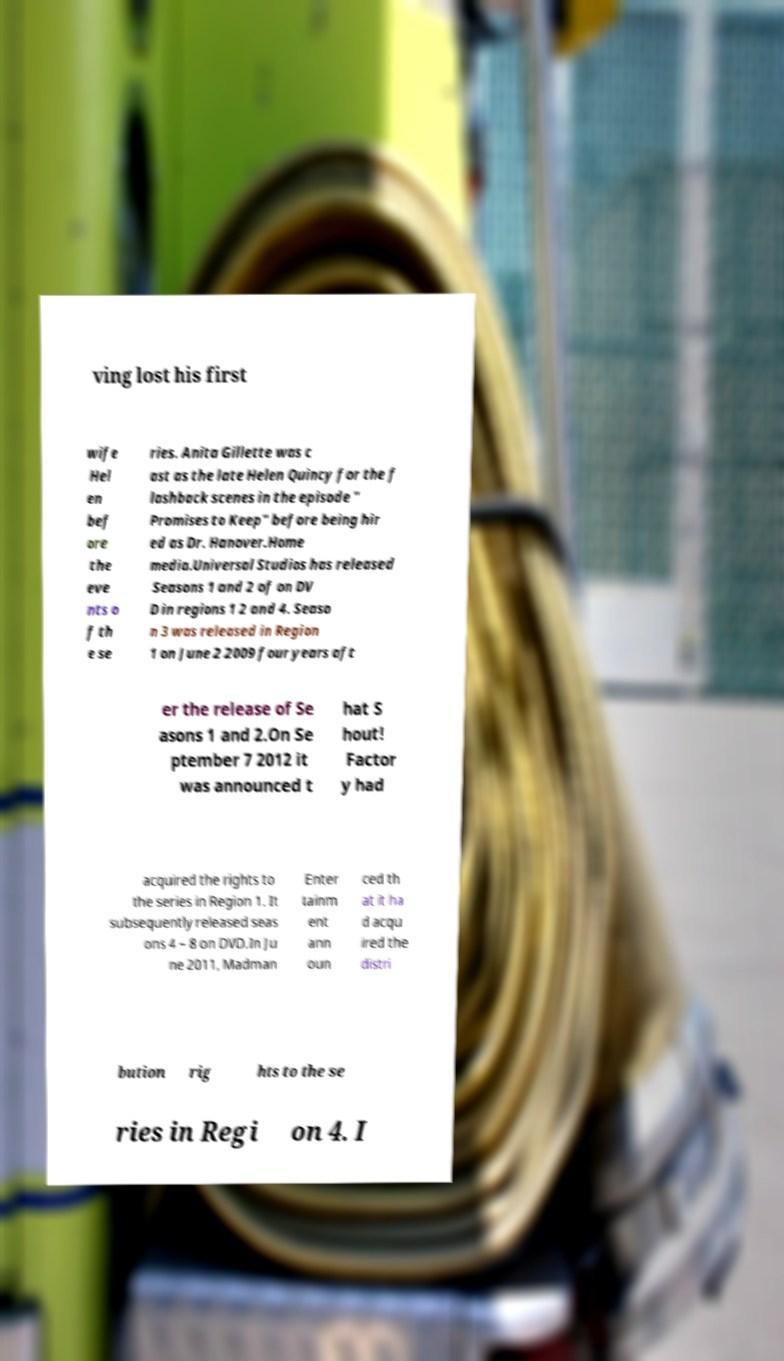There's text embedded in this image that I need extracted. Can you transcribe it verbatim? ving lost his first wife Hel en bef ore the eve nts o f th e se ries. Anita Gillette was c ast as the late Helen Quincy for the f lashback scenes in the episode " Promises to Keep" before being hir ed as Dr. Hanover.Home media.Universal Studios has released Seasons 1 and 2 of on DV D in regions 1 2 and 4. Seaso n 3 was released in Region 1 on June 2 2009 four years aft er the release of Se asons 1 and 2.On Se ptember 7 2012 it was announced t hat S hout! Factor y had acquired the rights to the series in Region 1. It subsequently released seas ons 4 – 8 on DVD.In Ju ne 2011, Madman Enter tainm ent ann oun ced th at it ha d acqu ired the distri bution rig hts to the se ries in Regi on 4. I 